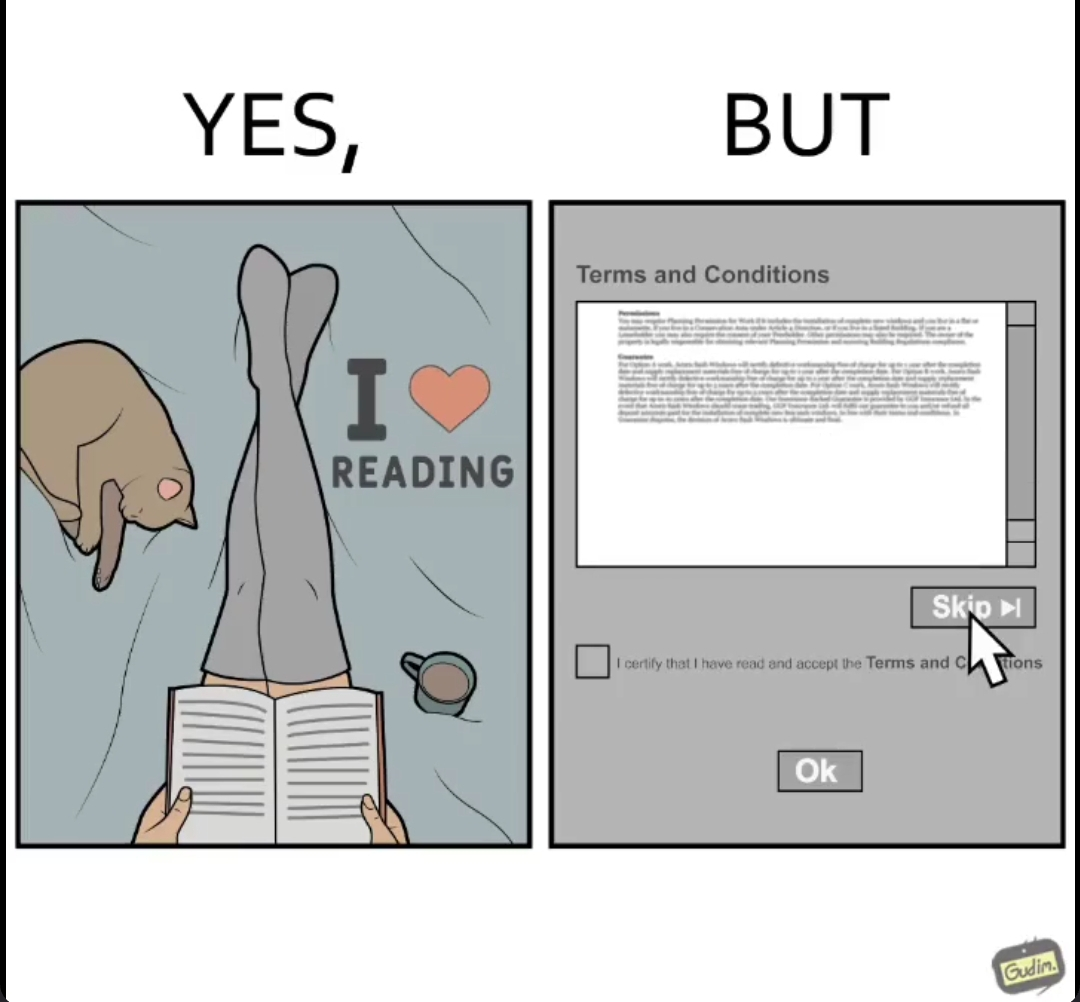Describe the satirical element in this image. the irony in this image is that people say that they like to read things while they instantly skip reading the terms and conditions when registering for anything online. 